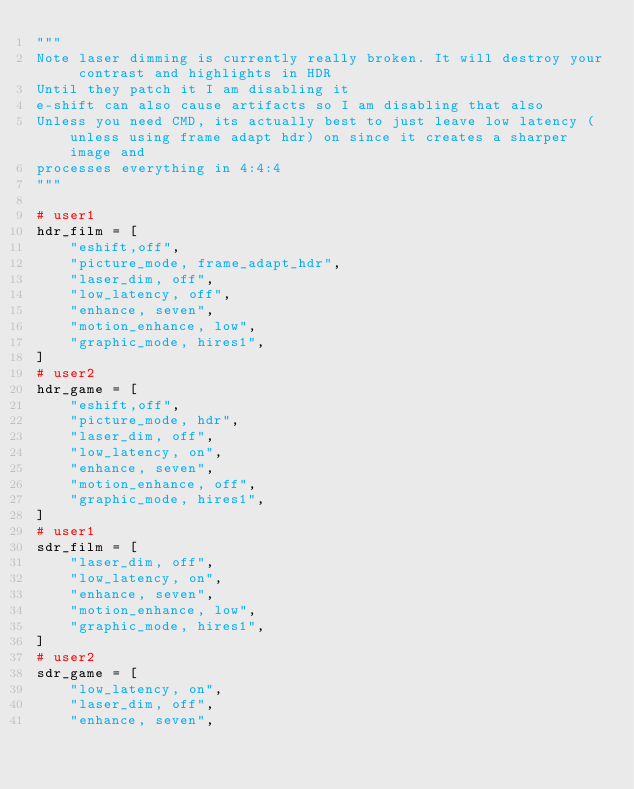<code> <loc_0><loc_0><loc_500><loc_500><_Python_>"""
Note laser dimming is currently really broken. It will destroy your contrast and highlights in HDR
Until they patch it I am disabling it
e-shift can also cause artifacts so I am disabling that also
Unless you need CMD, its actually best to just leave low latency (unless using frame adapt hdr) on since it creates a sharper image and
processes everything in 4:4:4
"""

# user1
hdr_film = [
    "eshift,off",
    "picture_mode, frame_adapt_hdr",
    "laser_dim, off",
    "low_latency, off",
    "enhance, seven",
    "motion_enhance, low",
    "graphic_mode, hires1",
]
# user2
hdr_game = [
    "eshift,off",
    "picture_mode, hdr",
    "laser_dim, off",
    "low_latency, on",
    "enhance, seven",
    "motion_enhance, off",
    "graphic_mode, hires1",
]
# user1
sdr_film = [
    "laser_dim, off",
    "low_latency, on",
    "enhance, seven",
    "motion_enhance, low",
    "graphic_mode, hires1",
]
# user2
sdr_game = [
    "low_latency, on",
    "laser_dim, off",
    "enhance, seven",</code> 